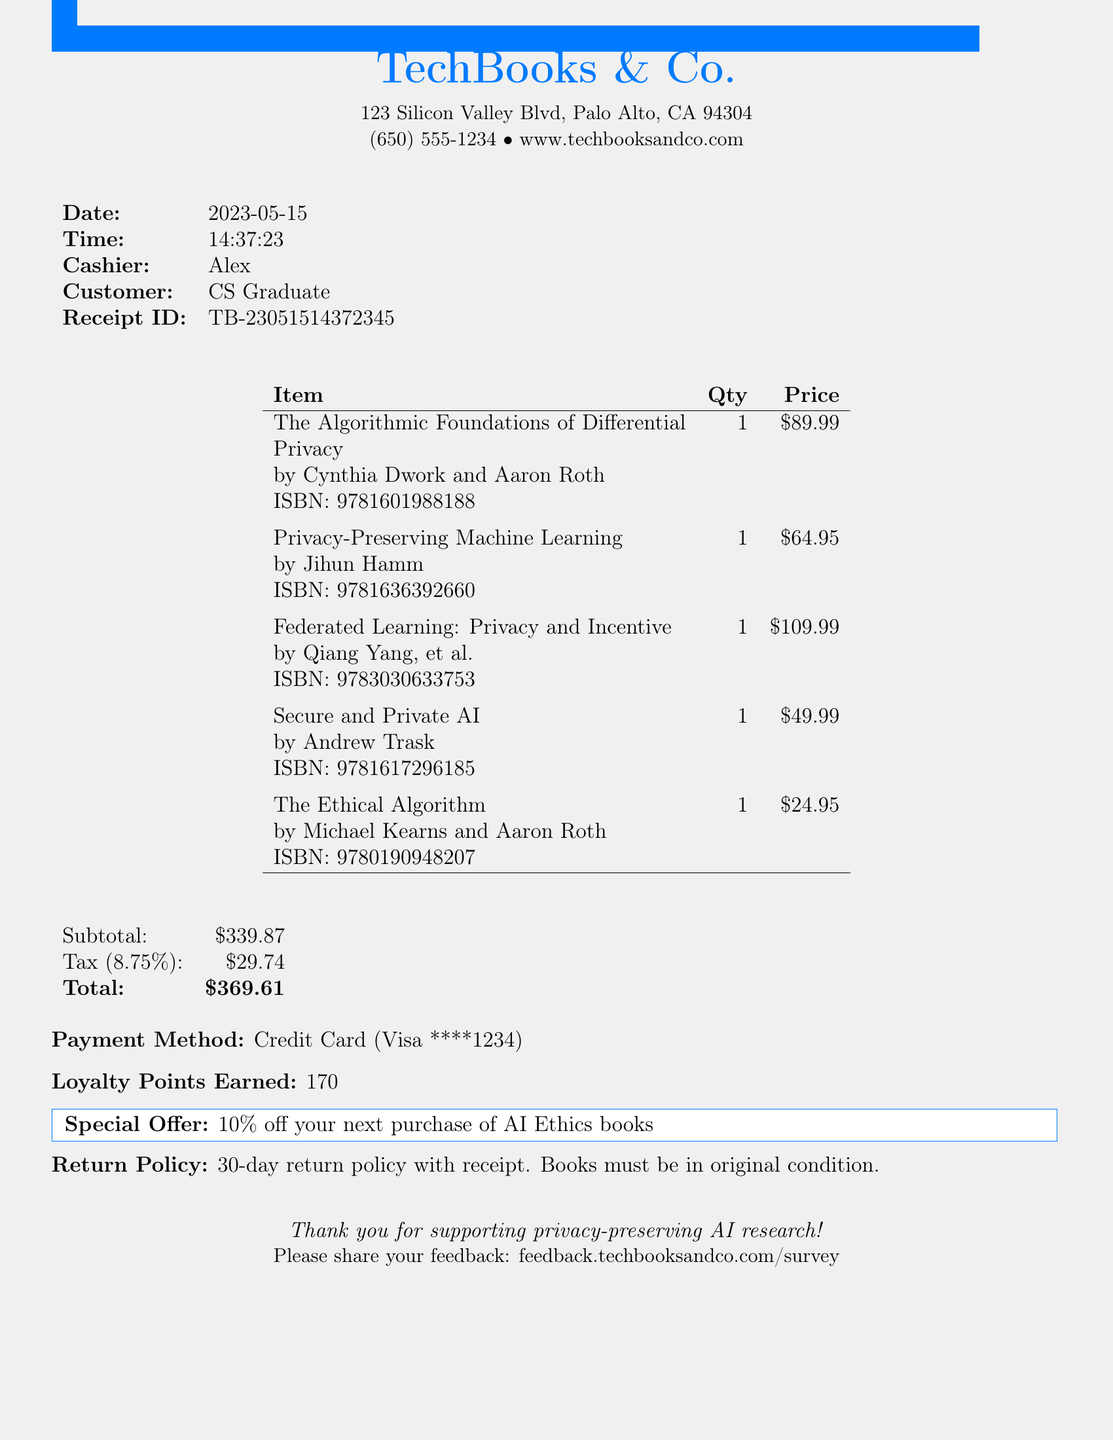What is the store name? The store name is found in the header of the receipt.
Answer: TechBooks & Co What is the date of the purchase? The date is specified in the receipt details.
Answer: 2023-05-15 Who is the cashier? The cashier's name is listed alongside the date and time of the transaction.
Answer: Alex What is the total amount spent? The total amount is the final price shown at the bottom of the receipt.
Answer: $369.61 How many loyalty points were earned? The number of loyalty points is indicated in the receipt details.
Answer: 170 Which book has the highest price? The prices of all items are listed, and comparison is needed to find the highest.
Answer: Federated Learning: Privacy and Incentive What is the return policy stated? The return policy is mentioned in the receipt details under return policy.
Answer: 30-day return policy with receipt. Books must be in original condition What special offer is available? The receipt includes a special offer towards the bottom.
Answer: 10% off your next purchase of AI Ethics books How many items were purchased? The number of items can be counted based on the list provided in the receipt.
Answer: 5 